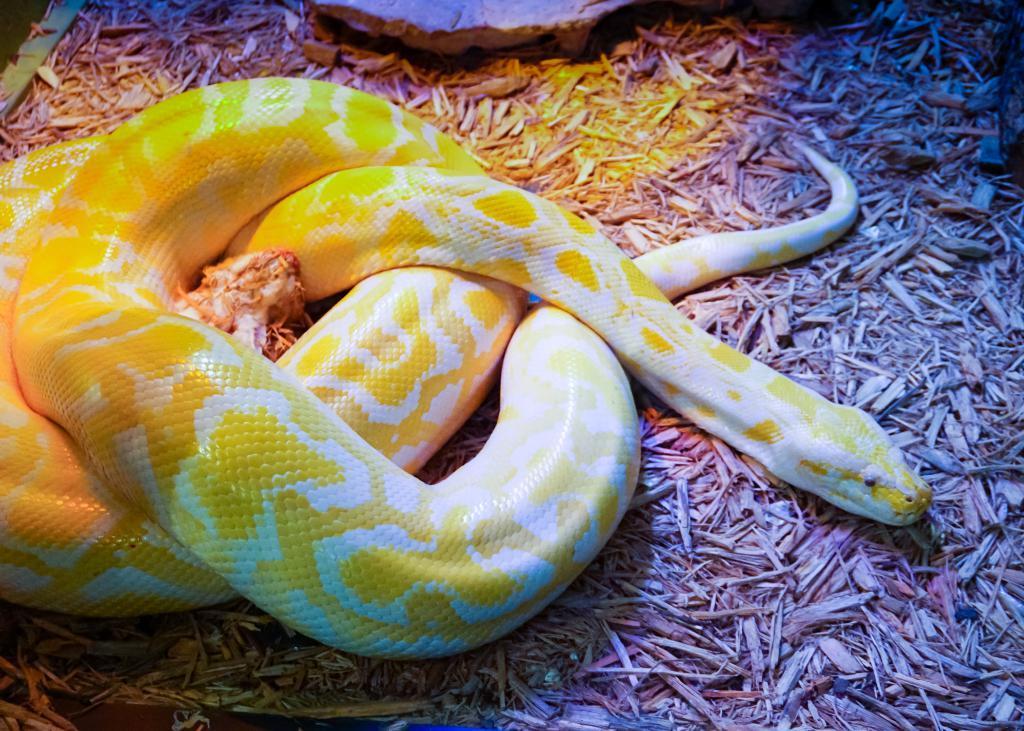Please provide a concise description of this image. In this image we can see a snake on the ground and there is a stone beside the snake. 